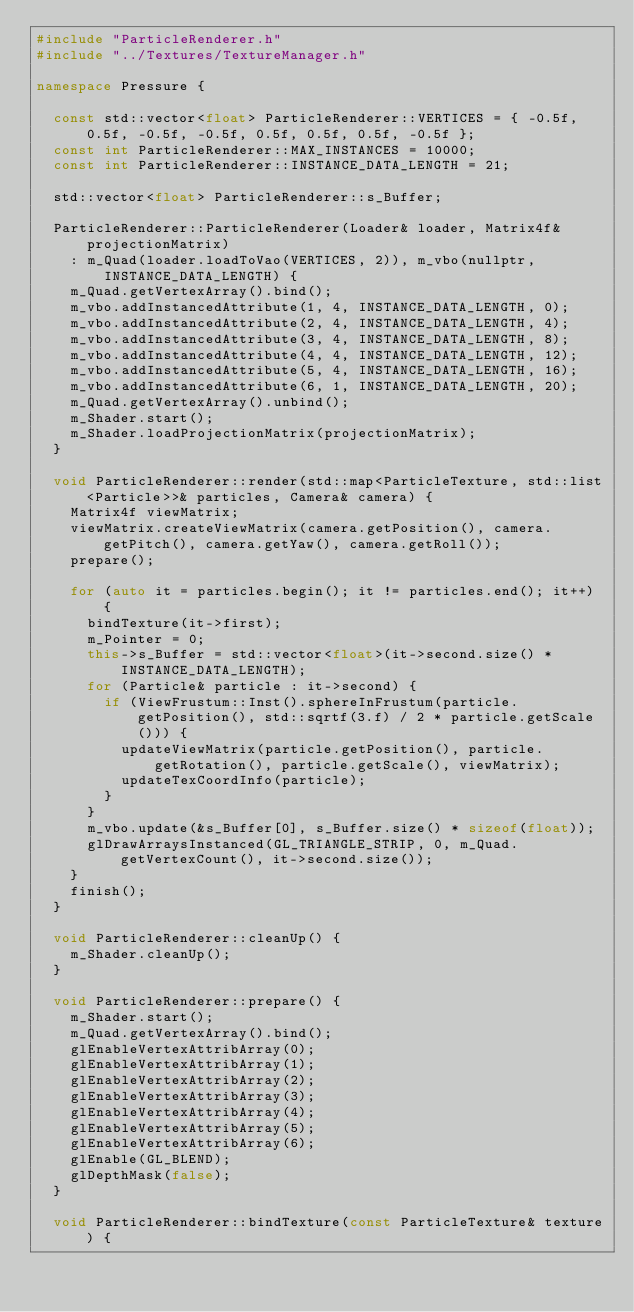Convert code to text. <code><loc_0><loc_0><loc_500><loc_500><_C++_>#include "ParticleRenderer.h"
#include "../Textures/TextureManager.h"

namespace Pressure {

	const std::vector<float> ParticleRenderer::VERTICES = { -0.5f, 0.5f, -0.5f, -0.5f, 0.5f, 0.5f, 0.5f, -0.5f };
	const int ParticleRenderer::MAX_INSTANCES = 10000;
	const int ParticleRenderer::INSTANCE_DATA_LENGTH = 21;

	std::vector<float> ParticleRenderer::s_Buffer;

	ParticleRenderer::ParticleRenderer(Loader& loader, Matrix4f& projectionMatrix)
		: m_Quad(loader.loadToVao(VERTICES, 2)), m_vbo(nullptr, INSTANCE_DATA_LENGTH) {
		m_Quad.getVertexArray().bind();
		m_vbo.addInstancedAttribute(1, 4, INSTANCE_DATA_LENGTH, 0);
		m_vbo.addInstancedAttribute(2, 4, INSTANCE_DATA_LENGTH, 4);
		m_vbo.addInstancedAttribute(3, 4, INSTANCE_DATA_LENGTH, 8);
		m_vbo.addInstancedAttribute(4, 4, INSTANCE_DATA_LENGTH, 12);
		m_vbo.addInstancedAttribute(5, 4, INSTANCE_DATA_LENGTH, 16);
		m_vbo.addInstancedAttribute(6, 1, INSTANCE_DATA_LENGTH, 20);
		m_Quad.getVertexArray().unbind();
		m_Shader.start();
		m_Shader.loadProjectionMatrix(projectionMatrix);
	}

	void ParticleRenderer::render(std::map<ParticleTexture, std::list<Particle>>& particles, Camera& camera) {
		Matrix4f viewMatrix;
		viewMatrix.createViewMatrix(camera.getPosition(), camera.getPitch(), camera.getYaw(), camera.getRoll());
		prepare();

		for (auto it = particles.begin(); it != particles.end(); it++) {
			bindTexture(it->first);
			m_Pointer = 0;
			this->s_Buffer = std::vector<float>(it->second.size() * INSTANCE_DATA_LENGTH);
			for (Particle& particle : it->second) {
				if (ViewFrustum::Inst().sphereInFrustum(particle.getPosition(), std::sqrtf(3.f) / 2 * particle.getScale())) {
					updateViewMatrix(particle.getPosition(), particle.getRotation(), particle.getScale(), viewMatrix);
					updateTexCoordInfo(particle);
				}
			}
			m_vbo.update(&s_Buffer[0], s_Buffer.size() * sizeof(float));
			glDrawArraysInstanced(GL_TRIANGLE_STRIP, 0, m_Quad.getVertexCount(), it->second.size());
		}
		finish();
	}

	void ParticleRenderer::cleanUp() {
		m_Shader.cleanUp();
	}

	void ParticleRenderer::prepare() {
		m_Shader.start();
		m_Quad.getVertexArray().bind();
		glEnableVertexAttribArray(0);
		glEnableVertexAttribArray(1);
		glEnableVertexAttribArray(2);
		glEnableVertexAttribArray(3);
		glEnableVertexAttribArray(4);
		glEnableVertexAttribArray(5);
		glEnableVertexAttribArray(6);
		glEnable(GL_BLEND);
		glDepthMask(false);
	}

	void ParticleRenderer::bindTexture(const ParticleTexture& texture) {</code> 